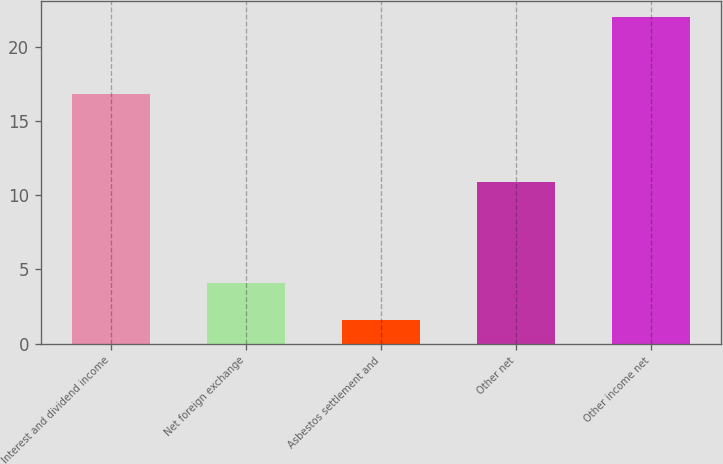Convert chart to OTSL. <chart><loc_0><loc_0><loc_500><loc_500><bar_chart><fcel>Interest and dividend income<fcel>Net foreign exchange<fcel>Asbestos settlement and<fcel>Other net<fcel>Other income net<nl><fcel>16.8<fcel>4.1<fcel>1.6<fcel>10.9<fcel>22<nl></chart> 